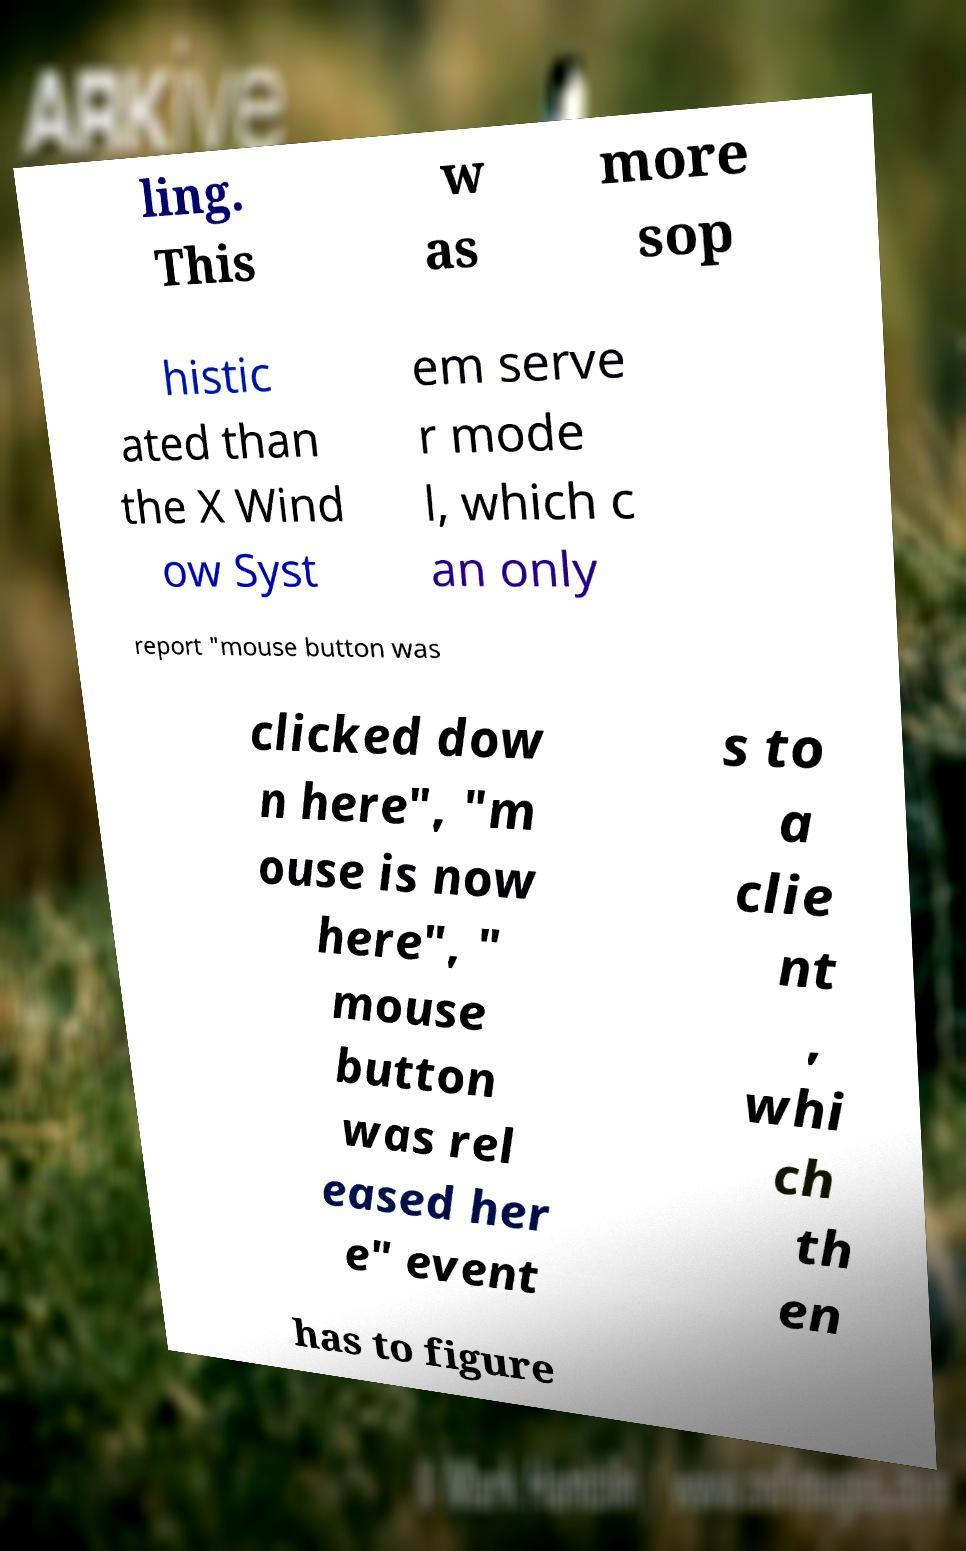Please read and relay the text visible in this image. What does it say? ling. This w as more sop histic ated than the X Wind ow Syst em serve r mode l, which c an only report "mouse button was clicked dow n here", "m ouse is now here", " mouse button was rel eased her e" event s to a clie nt , whi ch th en has to figure 